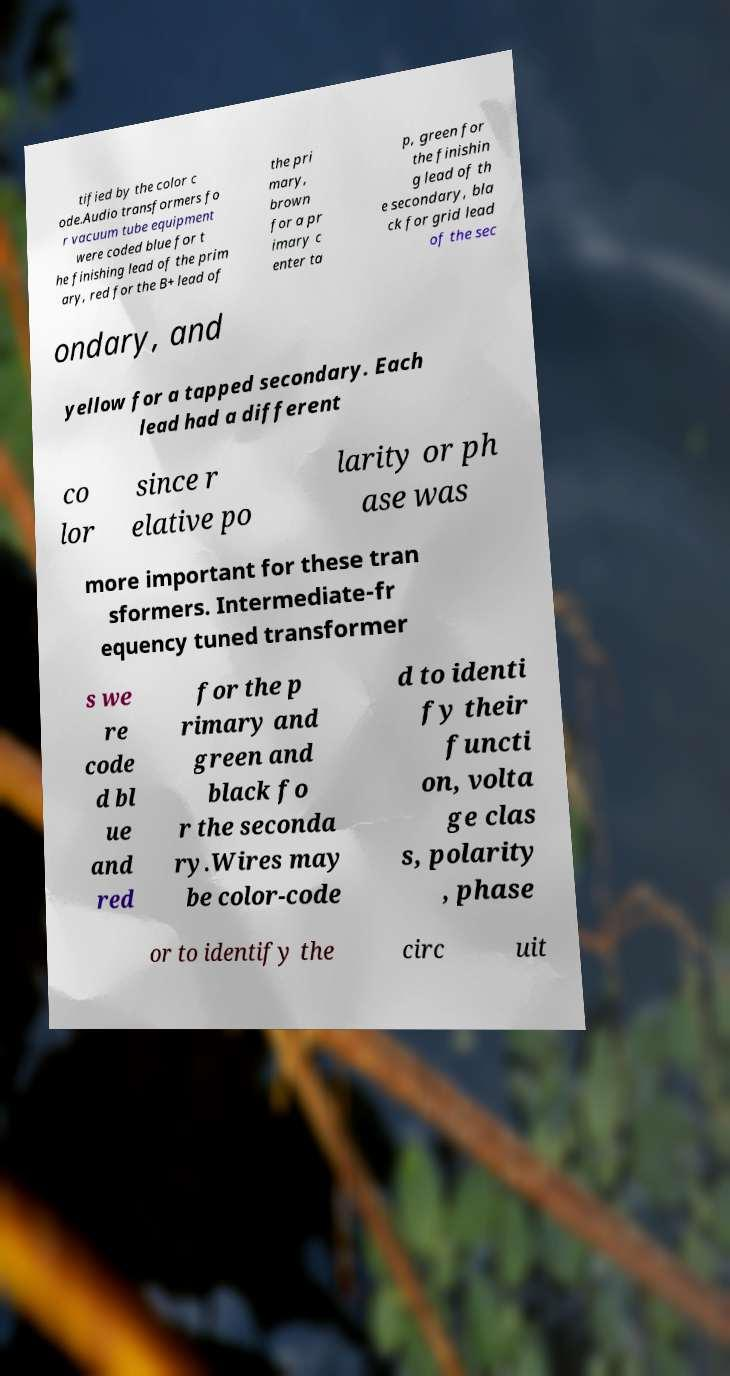Could you extract and type out the text from this image? tified by the color c ode.Audio transformers fo r vacuum tube equipment were coded blue for t he finishing lead of the prim ary, red for the B+ lead of the pri mary, brown for a pr imary c enter ta p, green for the finishin g lead of th e secondary, bla ck for grid lead of the sec ondary, and yellow for a tapped secondary. Each lead had a different co lor since r elative po larity or ph ase was more important for these tran sformers. Intermediate-fr equency tuned transformer s we re code d bl ue and red for the p rimary and green and black fo r the seconda ry.Wires may be color-code d to identi fy their functi on, volta ge clas s, polarity , phase or to identify the circ uit 